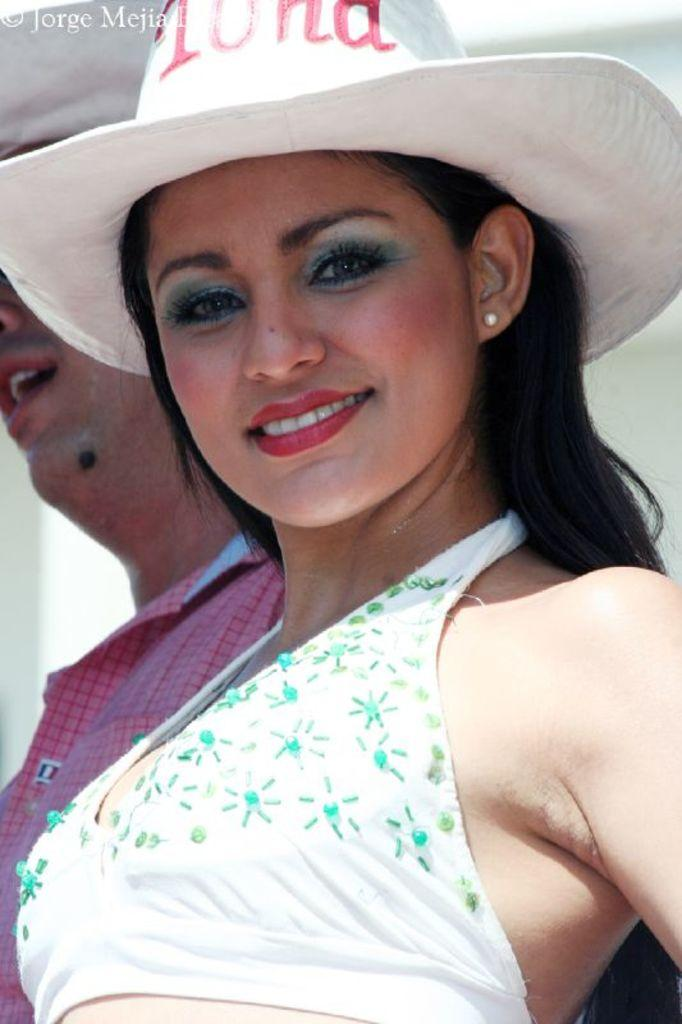How many people are in the image? There are two persons in the image. What are the persons wearing on their heads? Both persons are wearing hats. Can you describe any additional features of the image? There is a watermark on the image. What type of science experiment can be seen in the image? There is no science experiment present in the image. What season is depicted in the image? The image does not depict a specific season, as there are no seasonal cues provided. How many pigs are visible in the image? There are no pigs present in the image. 